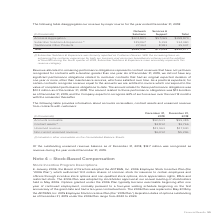According to Adtran's financial document, How much of the outstanding unearned revenue balance as of December 31, 2018 was recognized as revenue in 2019? According to the financial document, $12.7 million. The relevant text states: "unearned revenue balance as of December 31, 2018, $12.7 million was recognized as revenue during the year ended December 31, 2019...." Also, What was the amount of Accounts Receivable in 2019? According to the financial document, $90,531 (in thousands). The relevant text states: "Accounts receivable $90,531 $99,385..." Also, What was the amount of Unearned revenue in 2019? According to the financial document, $11,963 (in thousands). The relevant text states: "Unearned revenue $11,963 $17,940..." Also, can you calculate: What was the change in contract assets between 2018 and 2019? Based on the calculation: $2,812-$3,766, the result is -954 (in thousands). This is based on the information: "Contract assets (1) $2,812 $3,766 Contract assets (1) $2,812 $3,766..." The key data points involved are: 2,812, 3,766. Also, can you calculate: What was the change in non-current unearned revenue between 2018 and 2019? Based on the calculation: $6,012-$5,296, the result is 716 (in thousands). This is based on the information: "Non-current unearned revenue $6,012 $5,296 Non-current unearned revenue $6,012 $5,296..." The key data points involved are: 5,296, 6,012. Also, can you calculate: What was the percentage change in unearned revenue between 2018 and 2019? To answer this question, I need to perform calculations using the financial data. The calculation is: ($11,963-$17,940)/$17,940, which equals -33.32 (percentage). This is based on the information: "Unearned revenue $11,963 $17,940 Unearned revenue $11,963 $17,940..." The key data points involved are: 11,963, 17,940. 